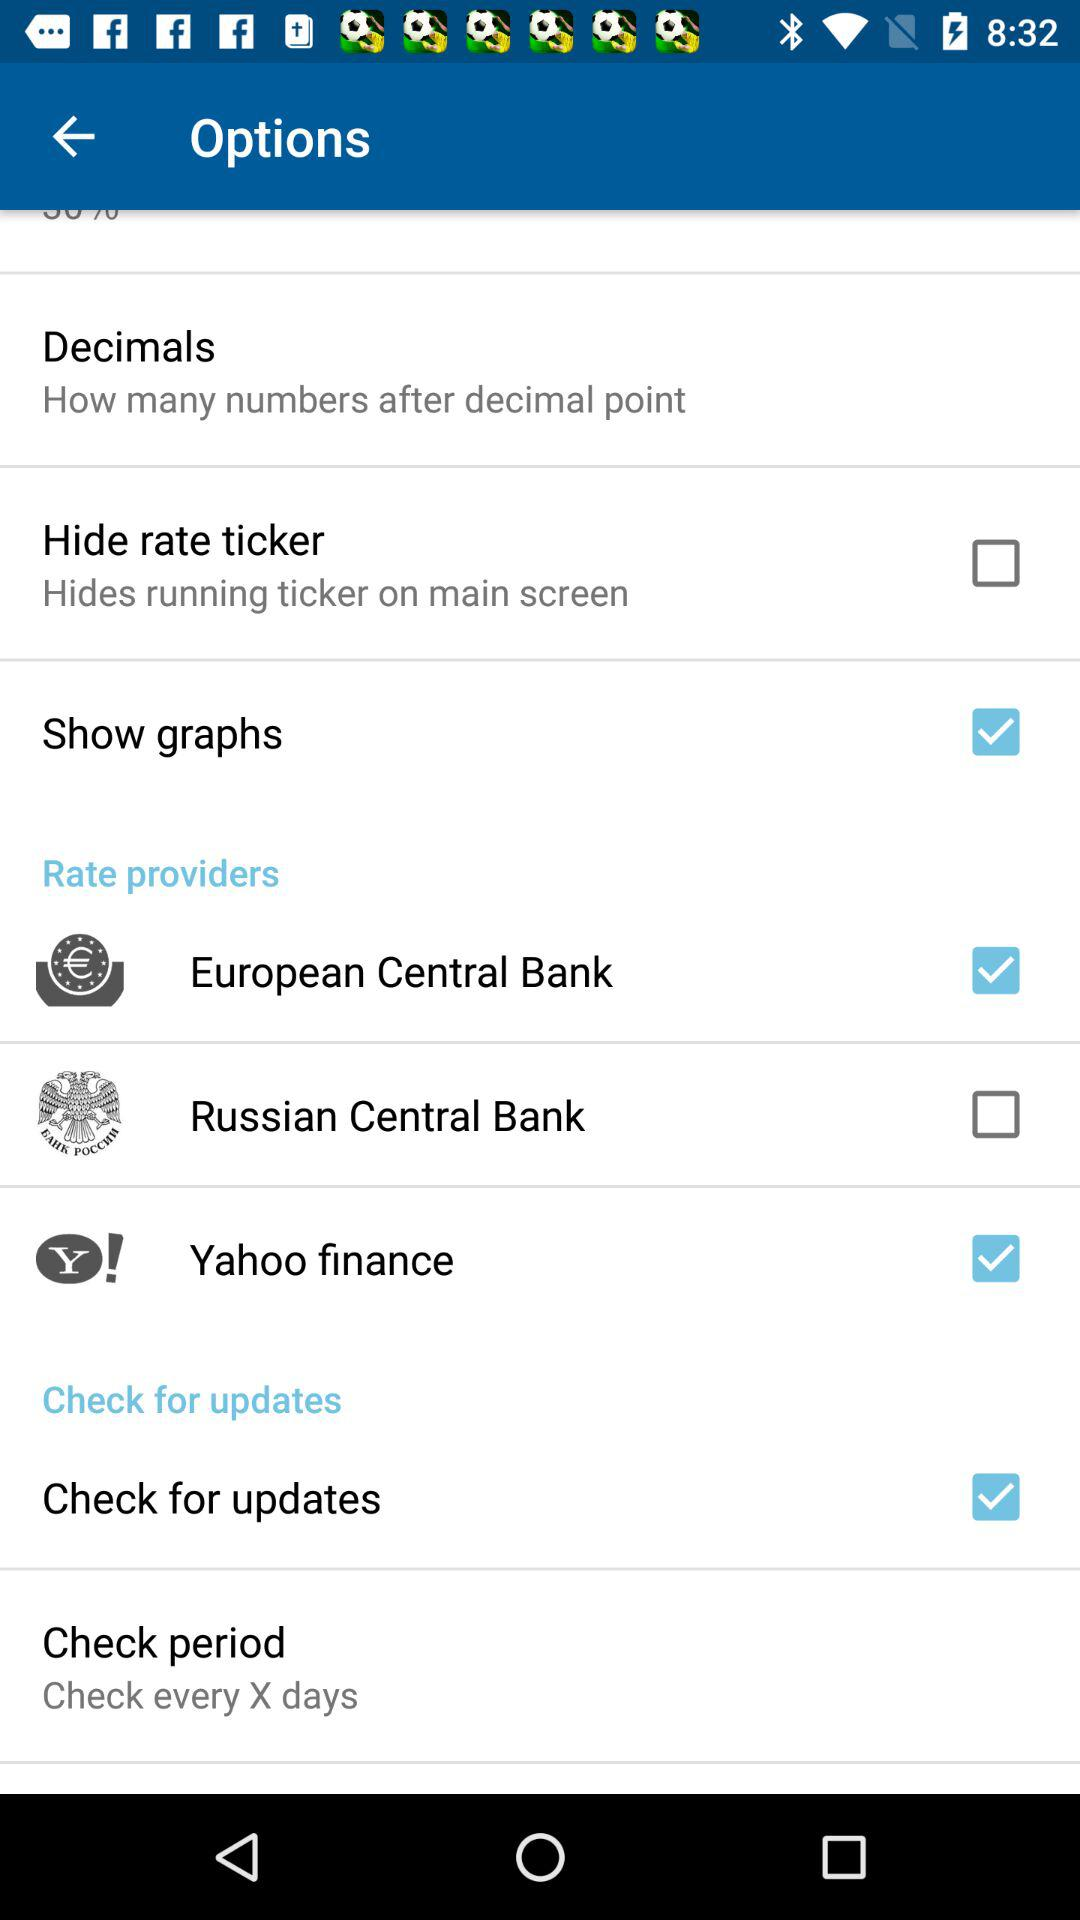What is the current status of the "Hide rate ticker"? The status is "off". 